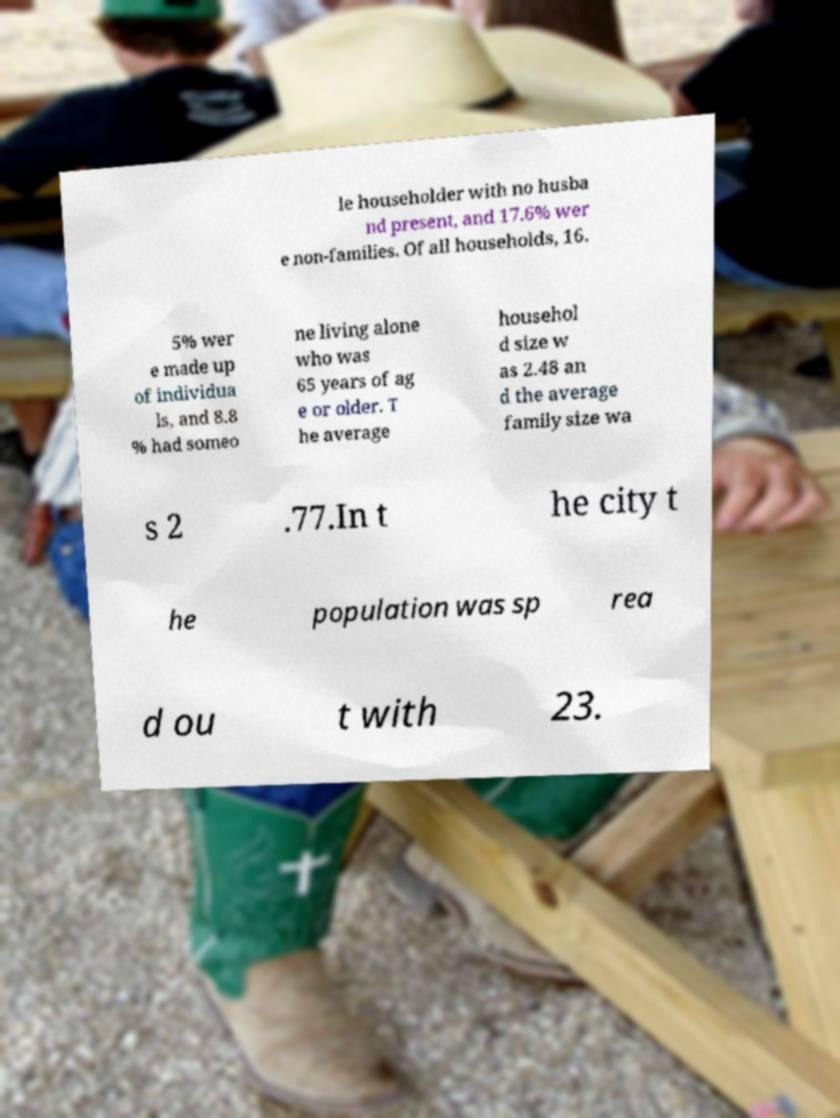Could you extract and type out the text from this image? le householder with no husba nd present, and 17.6% wer e non-families. Of all households, 16. 5% wer e made up of individua ls, and 8.8 % had someo ne living alone who was 65 years of ag e or older. T he average househol d size w as 2.48 an d the average family size wa s 2 .77.In t he city t he population was sp rea d ou t with 23. 